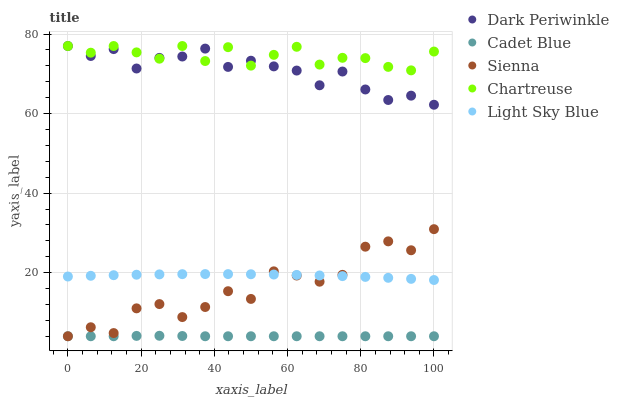Does Cadet Blue have the minimum area under the curve?
Answer yes or no. Yes. Does Chartreuse have the maximum area under the curve?
Answer yes or no. Yes. Does Chartreuse have the minimum area under the curve?
Answer yes or no. No. Does Cadet Blue have the maximum area under the curve?
Answer yes or no. No. Is Cadet Blue the smoothest?
Answer yes or no. Yes. Is Sienna the roughest?
Answer yes or no. Yes. Is Chartreuse the smoothest?
Answer yes or no. No. Is Chartreuse the roughest?
Answer yes or no. No. Does Sienna have the lowest value?
Answer yes or no. Yes. Does Chartreuse have the lowest value?
Answer yes or no. No. Does Dark Periwinkle have the highest value?
Answer yes or no. Yes. Does Cadet Blue have the highest value?
Answer yes or no. No. Is Sienna less than Dark Periwinkle?
Answer yes or no. Yes. Is Dark Periwinkle greater than Sienna?
Answer yes or no. Yes. Does Chartreuse intersect Dark Periwinkle?
Answer yes or no. Yes. Is Chartreuse less than Dark Periwinkle?
Answer yes or no. No. Is Chartreuse greater than Dark Periwinkle?
Answer yes or no. No. Does Sienna intersect Dark Periwinkle?
Answer yes or no. No. 